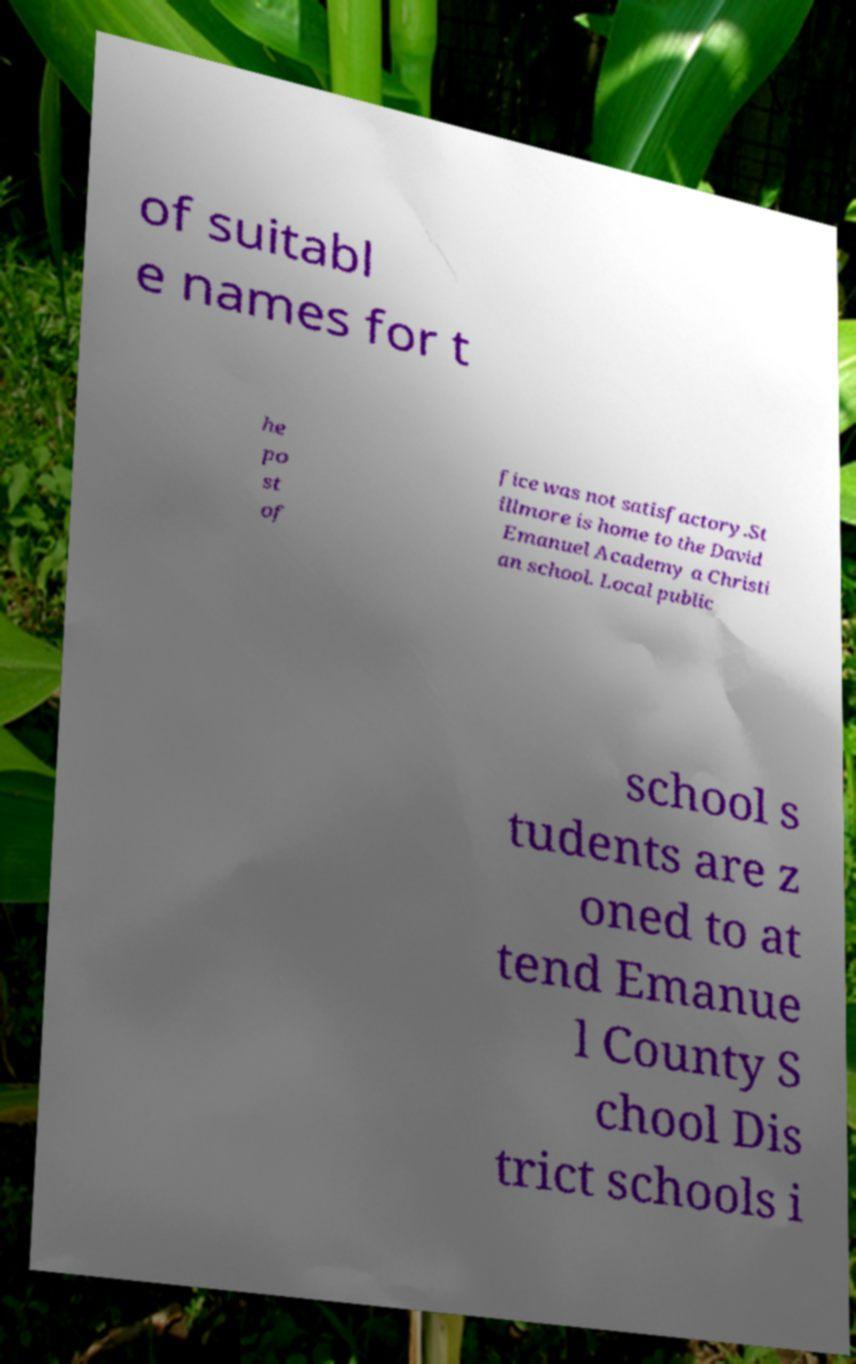Please read and relay the text visible in this image. What does it say? of suitabl e names for t he po st of fice was not satisfactory.St illmore is home to the David Emanuel Academy a Christi an school. Local public school s tudents are z oned to at tend Emanue l County S chool Dis trict schools i 